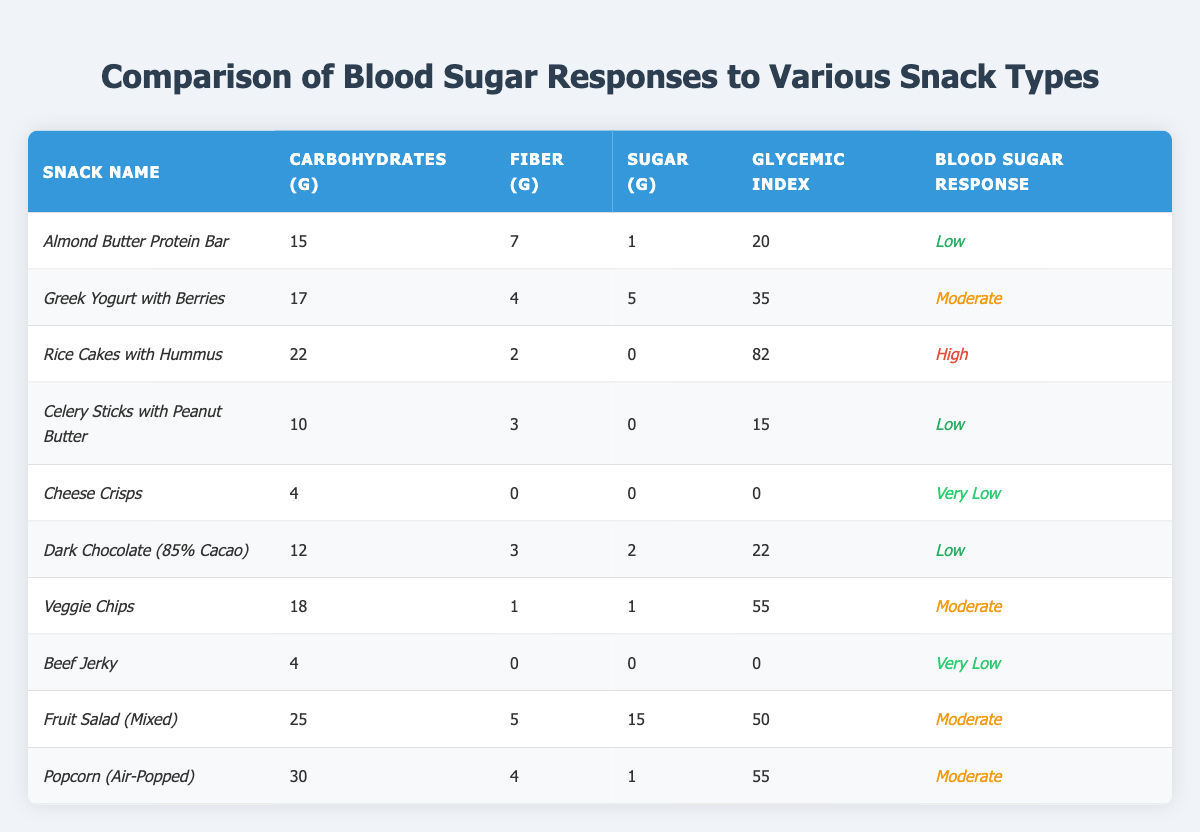What is the glycemic index of the *Celery Sticks with Peanut Butter*? The glycemic index is listed directly in the table for this snack. It shows a value of 15.
Answer: 15 Which snack has the highest blood sugar response? The blood sugar response is listed for each snack, and the snack with the highest response marked is *Rice Cakes with Hummus*, having a response of *High*.
Answer: Rice Cakes with Hummus How many grams of carbohydrates are in *Cheese Crisps*? The table provides the carbohydrate content directly, which is 4 grams for *Cheese Crisps*.
Answer: 4 grams What is the average amount of fiber in the snacks that have a low blood sugar response? The snacks with low blood sugar response are *Almond Butter Protein Bar*, *Celery Sticks with Peanut Butter*, and *Dark Chocolate (85% Cacao)* with fiber values 7, 3, and 3 respectively. The average is (7 + 3 + 3) / 3 = 4.33.
Answer: 4.33 grams Is the number of carbohydrates in *Beef Jerky* equal to that in *Cheese Crisps*? Both snacks have 4 grams of carbohydrates as indicated in their respective entries in the table. Therefore, this statement is true.
Answer: Yes Which snacks have a moderate blood sugar response? The snacks listed with a moderate response are *Greek Yogurt with Berries*, *Veggie Chips*, *Fruit Salad (Mixed)*, and *Popcorn (Air-Popped)*.
Answer: 4 snacks What is the total amount of sugar in the snacks with a very low blood sugar response? The snacks with a very low blood sugar response are *Cheese Crisps* and *Beef Jerky*, both of which have 0 grams of sugar. The total sugar is 0 + 0 = 0 grams.
Answer: 0 grams How does the glycemic index of *Dark Chocolate (85% Cacao)* compare to that of *Rice Cakes with Hummus*? The glycemic index for *Dark Chocolate* is 22, and for *Rice Cakes with Hummus*, it is 82. Comparing these values, *Dark Chocolate* has a significantly lower glycemic index than *Rice Cakes with Hummus*.
Answer: Lower Which snack has the lowest sugar content and what is its blood sugar response? The snack with the lowest sugar content is *Cheese Crisps*, which contains 0 grams of sugar and has a blood sugar response of *Very Low*.
Answer: Cheese Crisps, Very Low What is the total carbohydrate content in the snacks labeled as having a low blood sugar response? The snacks with a low blood sugar response are *Almond Butter Protein Bar*, *Celery Sticks with Peanut Butter*, and *Dark Chocolate (85% Cacao)*, with carbohydrate contents of 15, 10, and 12 grams respectively, summing to 15 + 10 + 12 = 37 grams.
Answer: 37 grams 